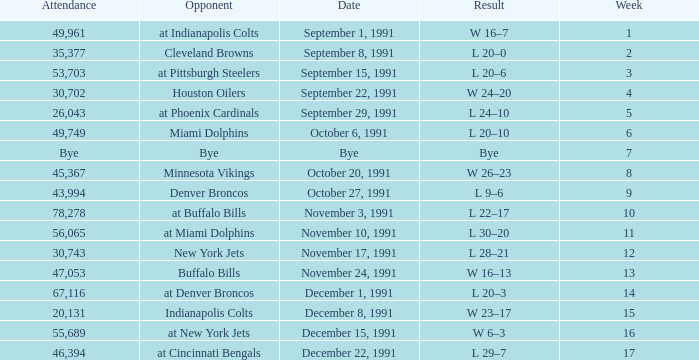Could you parse the entire table as a dict? {'header': ['Attendance', 'Opponent', 'Date', 'Result', 'Week'], 'rows': [['49,961', 'at Indianapolis Colts', 'September 1, 1991', 'W 16–7', '1'], ['35,377', 'Cleveland Browns', 'September 8, 1991', 'L 20–0', '2'], ['53,703', 'at Pittsburgh Steelers', 'September 15, 1991', 'L 20–6', '3'], ['30,702', 'Houston Oilers', 'September 22, 1991', 'W 24–20', '4'], ['26,043', 'at Phoenix Cardinals', 'September 29, 1991', 'L 24–10', '5'], ['49,749', 'Miami Dolphins', 'October 6, 1991', 'L 20–10', '6'], ['Bye', 'Bye', 'Bye', 'Bye', '7'], ['45,367', 'Minnesota Vikings', 'October 20, 1991', 'W 26–23', '8'], ['43,994', 'Denver Broncos', 'October 27, 1991', 'L 9–6', '9'], ['78,278', 'at Buffalo Bills', 'November 3, 1991', 'L 22–17', '10'], ['56,065', 'at Miami Dolphins', 'November 10, 1991', 'L 30–20', '11'], ['30,743', 'New York Jets', 'November 17, 1991', 'L 28–21', '12'], ['47,053', 'Buffalo Bills', 'November 24, 1991', 'W 16–13', '13'], ['67,116', 'at Denver Broncos', 'December 1, 1991', 'L 20–3', '14'], ['20,131', 'Indianapolis Colts', 'December 8, 1991', 'W 23–17', '15'], ['55,689', 'at New York Jets', 'December 15, 1991', 'W 6–3', '16'], ['46,394', 'at Cincinnati Bengals', 'December 22, 1991', 'L 29–7', '17']]} Who did the Patriots play in week 4? Houston Oilers. 